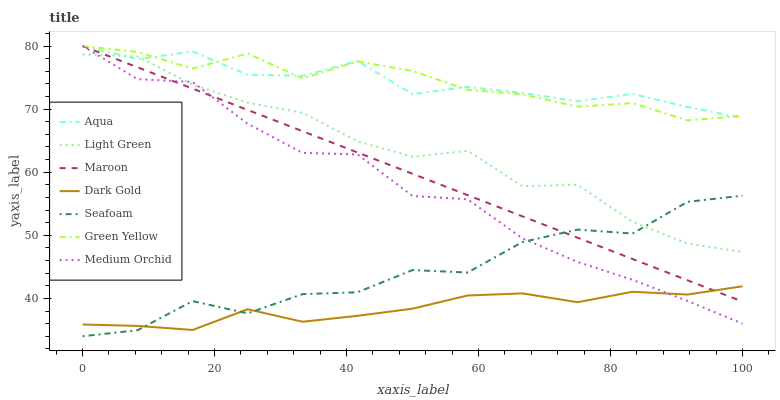Does Dark Gold have the minimum area under the curve?
Answer yes or no. Yes. Does Medium Orchid have the minimum area under the curve?
Answer yes or no. No. Does Medium Orchid have the maximum area under the curve?
Answer yes or no. No. Is Medium Orchid the smoothest?
Answer yes or no. No. Is Medium Orchid the roughest?
Answer yes or no. No. Does Medium Orchid have the lowest value?
Answer yes or no. No. Does Seafoam have the highest value?
Answer yes or no. No. Is Dark Gold less than Light Green?
Answer yes or no. Yes. Is Green Yellow greater than Seafoam?
Answer yes or no. Yes. Does Dark Gold intersect Light Green?
Answer yes or no. No. 